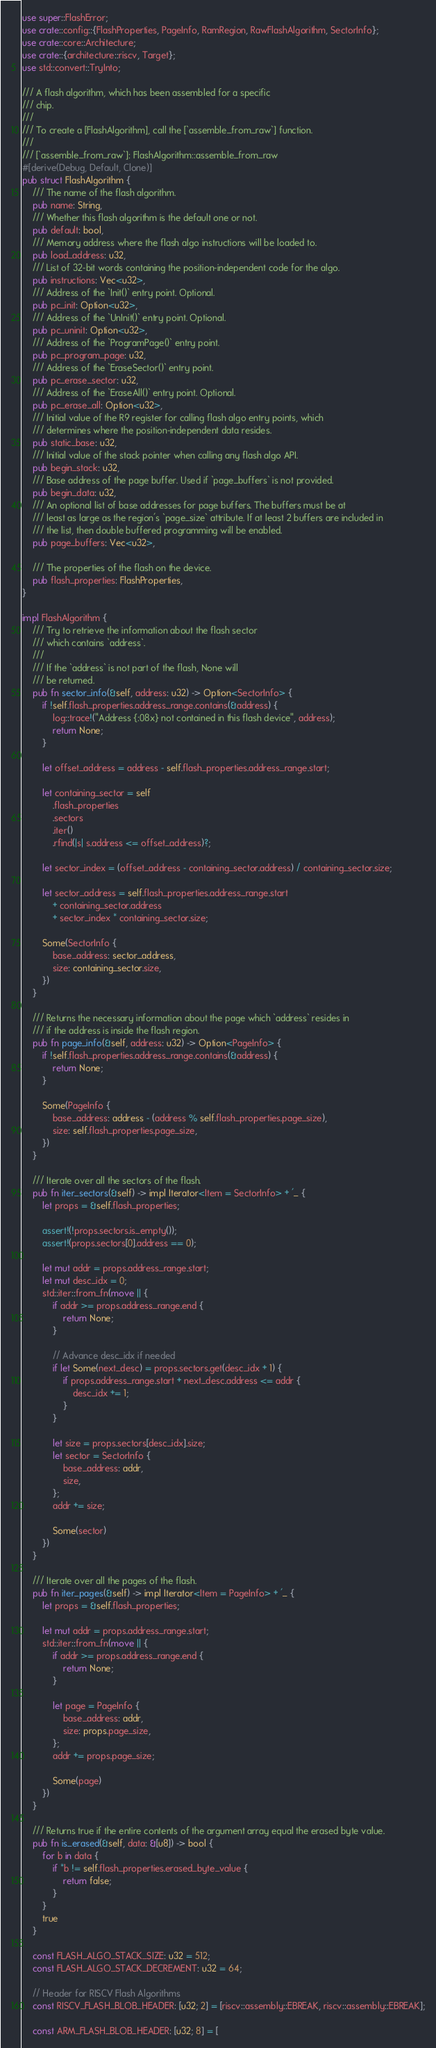Convert code to text. <code><loc_0><loc_0><loc_500><loc_500><_Rust_>use super::FlashError;
use crate::config::{FlashProperties, PageInfo, RamRegion, RawFlashAlgorithm, SectorInfo};
use crate::core::Architecture;
use crate::{architecture::riscv, Target};
use std::convert::TryInto;

/// A flash algorithm, which has been assembled for a specific
/// chip.
///
/// To create a [FlashAlgorithm], call the [`assemble_from_raw`] function.
///
/// [`assemble_from_raw`]: FlashAlgorithm::assemble_from_raw
#[derive(Debug, Default, Clone)]
pub struct FlashAlgorithm {
    /// The name of the flash algorithm.
    pub name: String,
    /// Whether this flash algorithm is the default one or not.
    pub default: bool,
    /// Memory address where the flash algo instructions will be loaded to.
    pub load_address: u32,
    /// List of 32-bit words containing the position-independent code for the algo.
    pub instructions: Vec<u32>,
    /// Address of the `Init()` entry point. Optional.
    pub pc_init: Option<u32>,
    /// Address of the `UnInit()` entry point. Optional.
    pub pc_uninit: Option<u32>,
    /// Address of the `ProgramPage()` entry point.
    pub pc_program_page: u32,
    /// Address of the `EraseSector()` entry point.
    pub pc_erase_sector: u32,
    /// Address of the `EraseAll()` entry point. Optional.
    pub pc_erase_all: Option<u32>,
    /// Initial value of the R9 register for calling flash algo entry points, which
    /// determines where the position-independent data resides.
    pub static_base: u32,
    /// Initial value of the stack pointer when calling any flash algo API.
    pub begin_stack: u32,
    /// Base address of the page buffer. Used if `page_buffers` is not provided.
    pub begin_data: u32,
    /// An optional list of base addresses for page buffers. The buffers must be at
    /// least as large as the region's `page_size` attribute. If at least 2 buffers are included in
    /// the list, then double buffered programming will be enabled.
    pub page_buffers: Vec<u32>,

    /// The properties of the flash on the device.
    pub flash_properties: FlashProperties,
}

impl FlashAlgorithm {
    /// Try to retrieve the information about the flash sector
    /// which contains `address`.
    ///
    /// If the `address` is not part of the flash, None will
    /// be returned.
    pub fn sector_info(&self, address: u32) -> Option<SectorInfo> {
        if !self.flash_properties.address_range.contains(&address) {
            log::trace!("Address {:08x} not contained in this flash device", address);
            return None;
        }

        let offset_address = address - self.flash_properties.address_range.start;

        let containing_sector = self
            .flash_properties
            .sectors
            .iter()
            .rfind(|s| s.address <= offset_address)?;

        let sector_index = (offset_address - containing_sector.address) / containing_sector.size;

        let sector_address = self.flash_properties.address_range.start
            + containing_sector.address
            + sector_index * containing_sector.size;

        Some(SectorInfo {
            base_address: sector_address,
            size: containing_sector.size,
        })
    }

    /// Returns the necessary information about the page which `address` resides in
    /// if the address is inside the flash region.
    pub fn page_info(&self, address: u32) -> Option<PageInfo> {
        if !self.flash_properties.address_range.contains(&address) {
            return None;
        }

        Some(PageInfo {
            base_address: address - (address % self.flash_properties.page_size),
            size: self.flash_properties.page_size,
        })
    }

    /// Iterate over all the sectors of the flash.
    pub fn iter_sectors(&self) -> impl Iterator<Item = SectorInfo> + '_ {
        let props = &self.flash_properties;

        assert!(!props.sectors.is_empty());
        assert!(props.sectors[0].address == 0);

        let mut addr = props.address_range.start;
        let mut desc_idx = 0;
        std::iter::from_fn(move || {
            if addr >= props.address_range.end {
                return None;
            }

            // Advance desc_idx if needed
            if let Some(next_desc) = props.sectors.get(desc_idx + 1) {
                if props.address_range.start + next_desc.address <= addr {
                    desc_idx += 1;
                }
            }

            let size = props.sectors[desc_idx].size;
            let sector = SectorInfo {
                base_address: addr,
                size,
            };
            addr += size;

            Some(sector)
        })
    }

    /// Iterate over all the pages of the flash.
    pub fn iter_pages(&self) -> impl Iterator<Item = PageInfo> + '_ {
        let props = &self.flash_properties;

        let mut addr = props.address_range.start;
        std::iter::from_fn(move || {
            if addr >= props.address_range.end {
                return None;
            }

            let page = PageInfo {
                base_address: addr,
                size: props.page_size,
            };
            addr += props.page_size;

            Some(page)
        })
    }

    /// Returns true if the entire contents of the argument array equal the erased byte value.
    pub fn is_erased(&self, data: &[u8]) -> bool {
        for b in data {
            if *b != self.flash_properties.erased_byte_value {
                return false;
            }
        }
        true
    }

    const FLASH_ALGO_STACK_SIZE: u32 = 512;
    const FLASH_ALGO_STACK_DECREMENT: u32 = 64;

    // Header for RISCV Flash Algorithms
    const RISCV_FLASH_BLOB_HEADER: [u32; 2] = [riscv::assembly::EBREAK, riscv::assembly::EBREAK];

    const ARM_FLASH_BLOB_HEADER: [u32; 8] = [</code> 